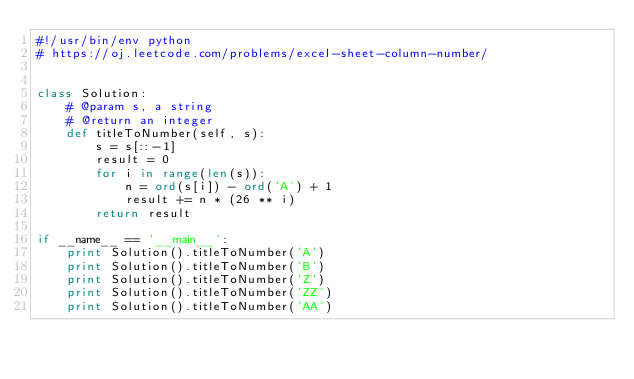<code> <loc_0><loc_0><loc_500><loc_500><_Python_>#!/usr/bin/env python
# https://oj.leetcode.com/problems/excel-sheet-column-number/


class Solution:
    # @param s, a string
    # @return an integer
    def titleToNumber(self, s):
        s = s[::-1]
        result = 0
        for i in range(len(s)):
            n = ord(s[i]) - ord('A') + 1
            result += n * (26 ** i)
        return result

if __name__ == '__main__':
    print Solution().titleToNumber('A')
    print Solution().titleToNumber('B')
    print Solution().titleToNumber('Z')
    print Solution().titleToNumber('ZZ')
    print Solution().titleToNumber('AA')
</code> 